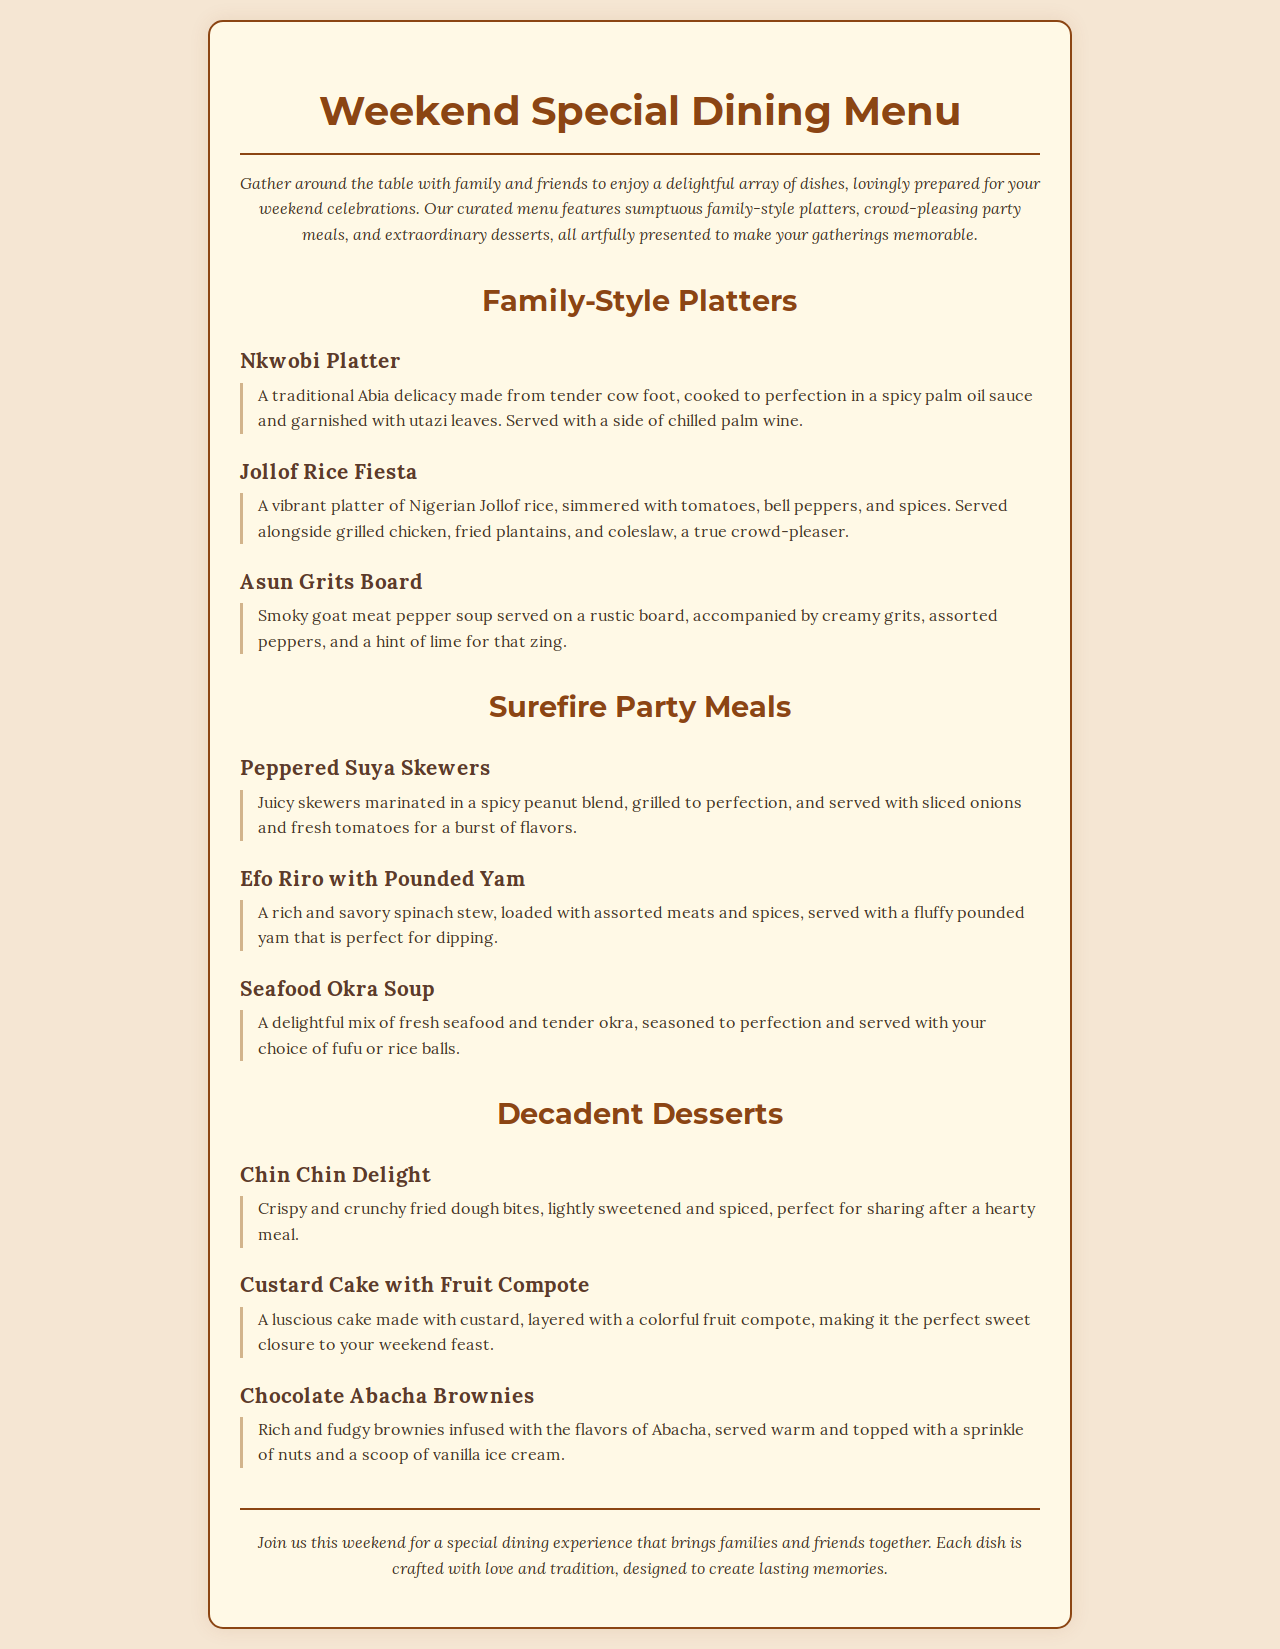What is the title of the menu? The title of the menu is prominently displayed at the top of the document, reading "Weekend Special Dining Menu."
Answer: Weekend Special Dining Menu What is the first dessert listed in the menu? The documents displays a list of desserts, starting with "Chin Chin Delight."
Answer: Chin Chin Delight How many family-style platters are featured? The menu section includes a count of family-style platters directly stated in the family-style platters section, totaling three.
Answer: Three What is a unique ingredient in the Efo Riro with Pounded Yam? The description of Efo Riro specifically mentions "assorted meats" as a key component.
Answer: Assorted meats What meal is served with chilled palm wine? The menu details that the "Nkwobi Platter" is served with chilled palm wine.
Answer: Nkwobi Platter Which dessert includes a scoop of vanilla ice cream? The "Chocolate Abacha Brownies" are topped with a scoop of vanilla ice cream as per its description.
Answer: Chocolate Abacha Brownies What type of meal is the "Seafood Okra Soup"? The menu categorizes "Seafood Okra Soup" under the section for surefire party meals.
Answer: Party meal What dish is described as a traditional Abia delicacy? The menu explicitly states that "Nkwobi Platter" is a traditional Abia delicacy.
Answer: Nkwobi Platter 